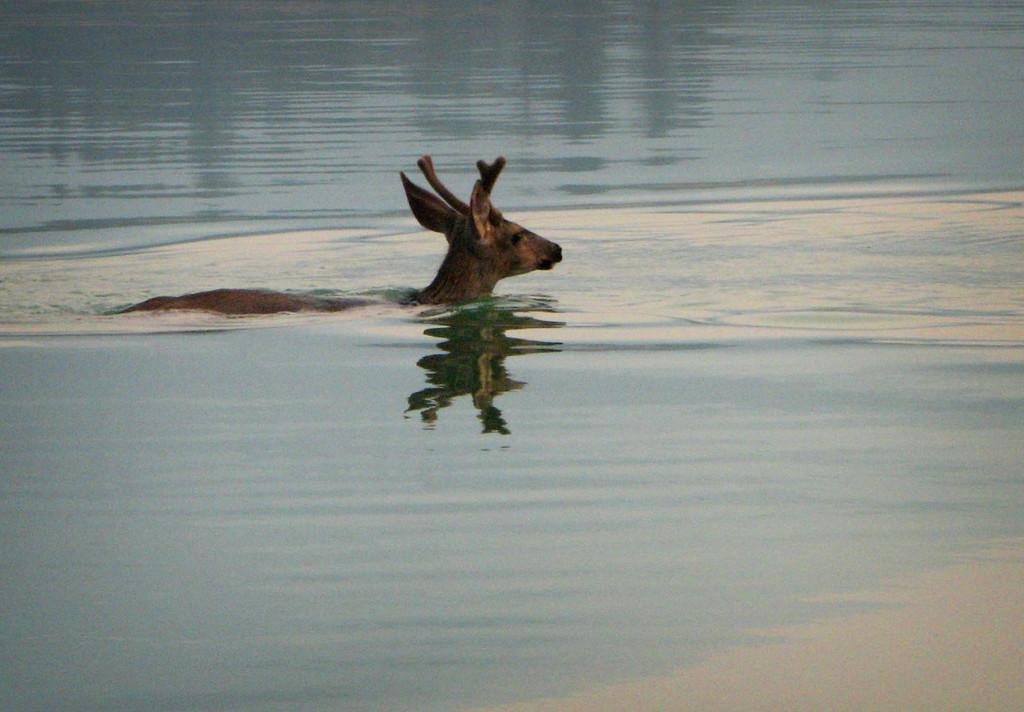What type of body of water is visible in the image? There is a sea in the image. Can you describe any living organisms present in the water? There is an animal in the water. What type of stocking can be seen floating on the surface of the lake in the image? There is no lake or stocking present in the image; it features a sea with an animal in the water. What type of leaf is visible on the ground near the animal in the image? There is no leaf present in the image; it only features a sea and an animal in the water. 